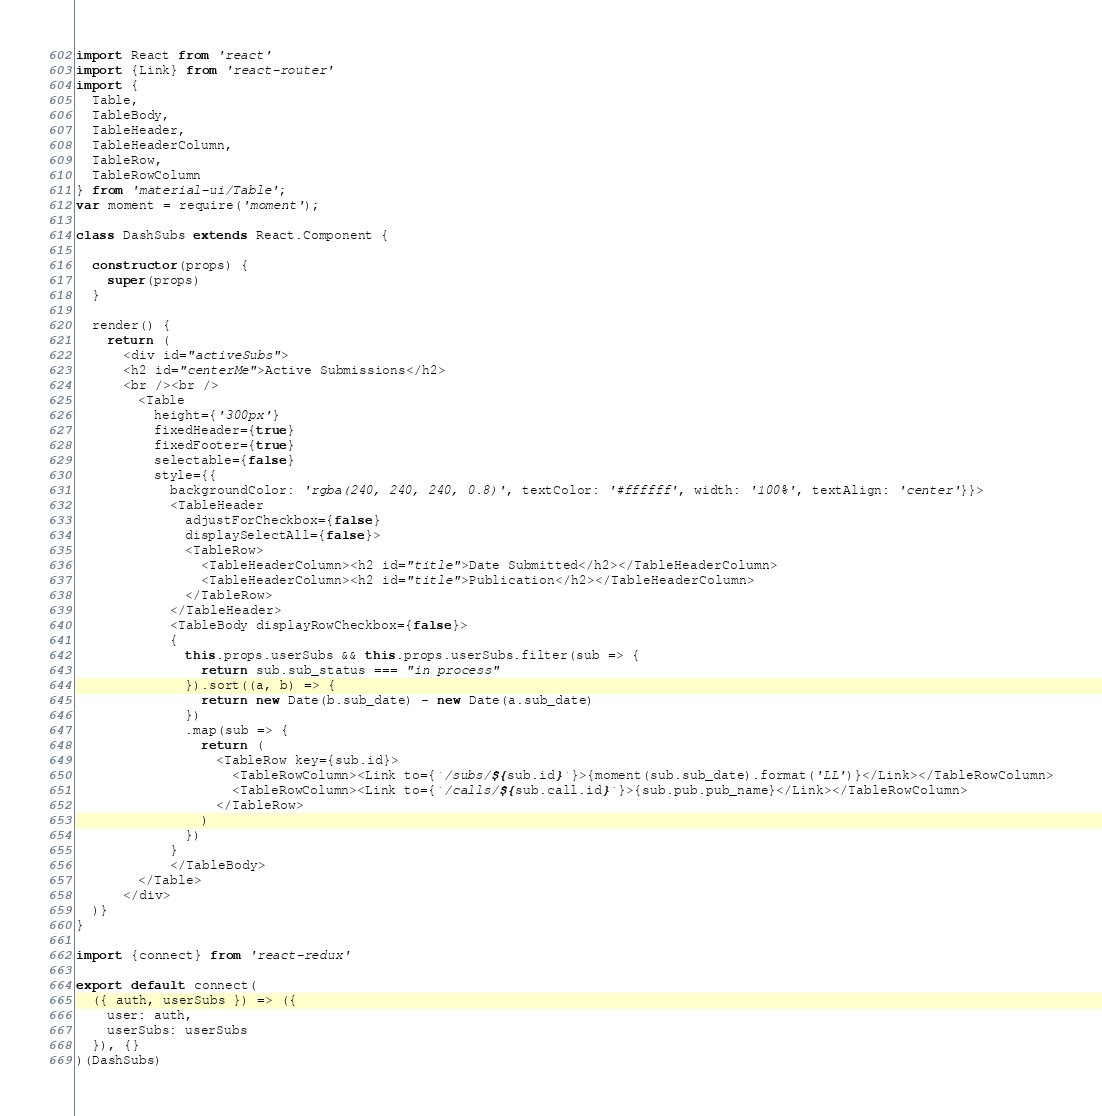<code> <loc_0><loc_0><loc_500><loc_500><_JavaScript_>import React from 'react'
import {Link} from 'react-router'
import {
  Table,
  TableBody,
  TableHeader,
  TableHeaderColumn,
  TableRow,
  TableRowColumn
} from 'material-ui/Table';
var moment = require('moment');

class DashSubs extends React.Component {
  
  constructor(props) {
    super(props)
  }

  render() {
    return (
      <div id="activeSubs">
      <h2 id="centerMe">Active Submissions</h2>
      <br /><br />
        <Table   
          height={'300px'}
          fixedHeader={true}
          fixedFooter={true}
          selectable={false}
          style={{
            backgroundColor: 'rgba(240, 240, 240, 0.8)', textColor: '#ffffff', width: '100%', textAlign: 'center'}}>
            <TableHeader 
              adjustForCheckbox={false}
              displaySelectAll={false}>
              <TableRow>
                <TableHeaderColumn><h2 id="title">Date Submitted</h2></TableHeaderColumn>
                <TableHeaderColumn><h2 id="title">Publication</h2></TableHeaderColumn>
              </TableRow>
            </TableHeader>
            <TableBody displayRowCheckbox={false}>
            {
              this.props.userSubs && this.props.userSubs.filter(sub => {
                return sub.sub_status === "in process"
              }).sort((a, b) => {
                return new Date(b.sub_date) - new Date(a.sub_date)
              })
              .map(sub => {
                return (
                  <TableRow key={sub.id}>
                    <TableRowColumn><Link to={`/subs/${sub.id}`}>{moment(sub.sub_date).format('LL')}</Link></TableRowColumn>
                    <TableRowColumn><Link to={`/calls/${sub.call.id}`}>{sub.pub.pub_name}</Link></TableRowColumn>
                  </TableRow>
                )
              })
            }
            </TableBody>
        </Table>
      </div>
  )}
}

import {connect} from 'react-redux'

export default connect(
  ({ auth, userSubs }) => ({ 
  	user: auth,
    userSubs: userSubs
  }), {}
)(DashSubs)</code> 